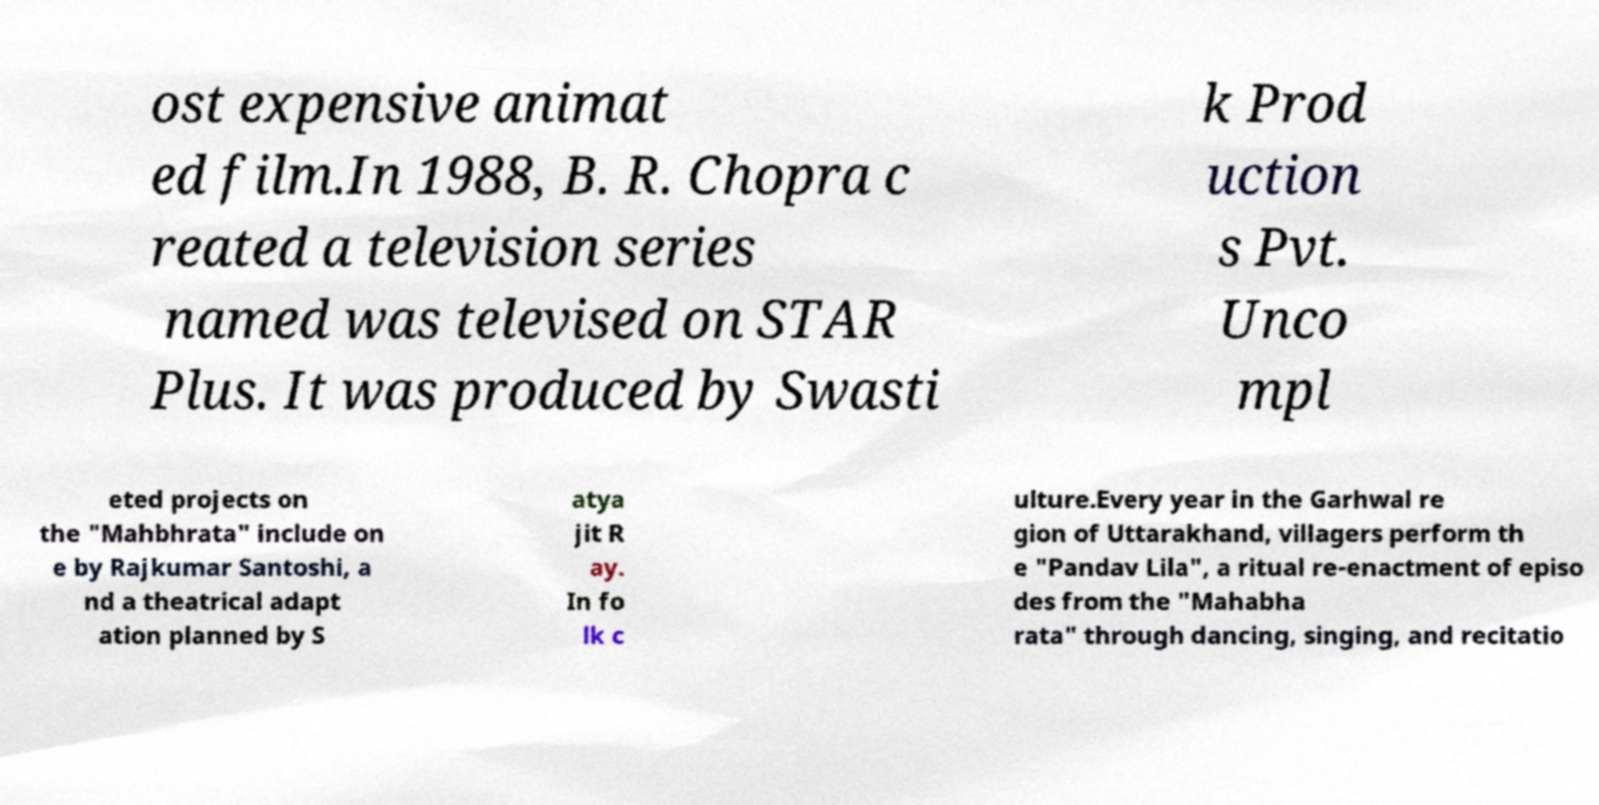Could you extract and type out the text from this image? ost expensive animat ed film.In 1988, B. R. Chopra c reated a television series named was televised on STAR Plus. It was produced by Swasti k Prod uction s Pvt. Unco mpl eted projects on the "Mahbhrata" include on e by Rajkumar Santoshi, a nd a theatrical adapt ation planned by S atya jit R ay. In fo lk c ulture.Every year in the Garhwal re gion of Uttarakhand, villagers perform th e "Pandav Lila", a ritual re-enactment of episo des from the "Mahabha rata" through dancing, singing, and recitatio 